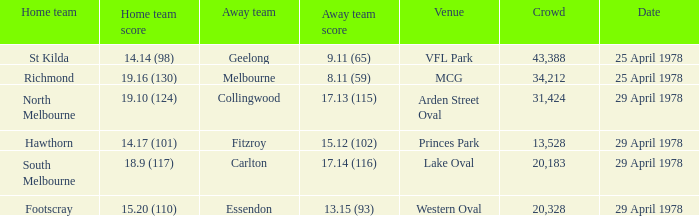Who was the home team at MCG? Richmond. 